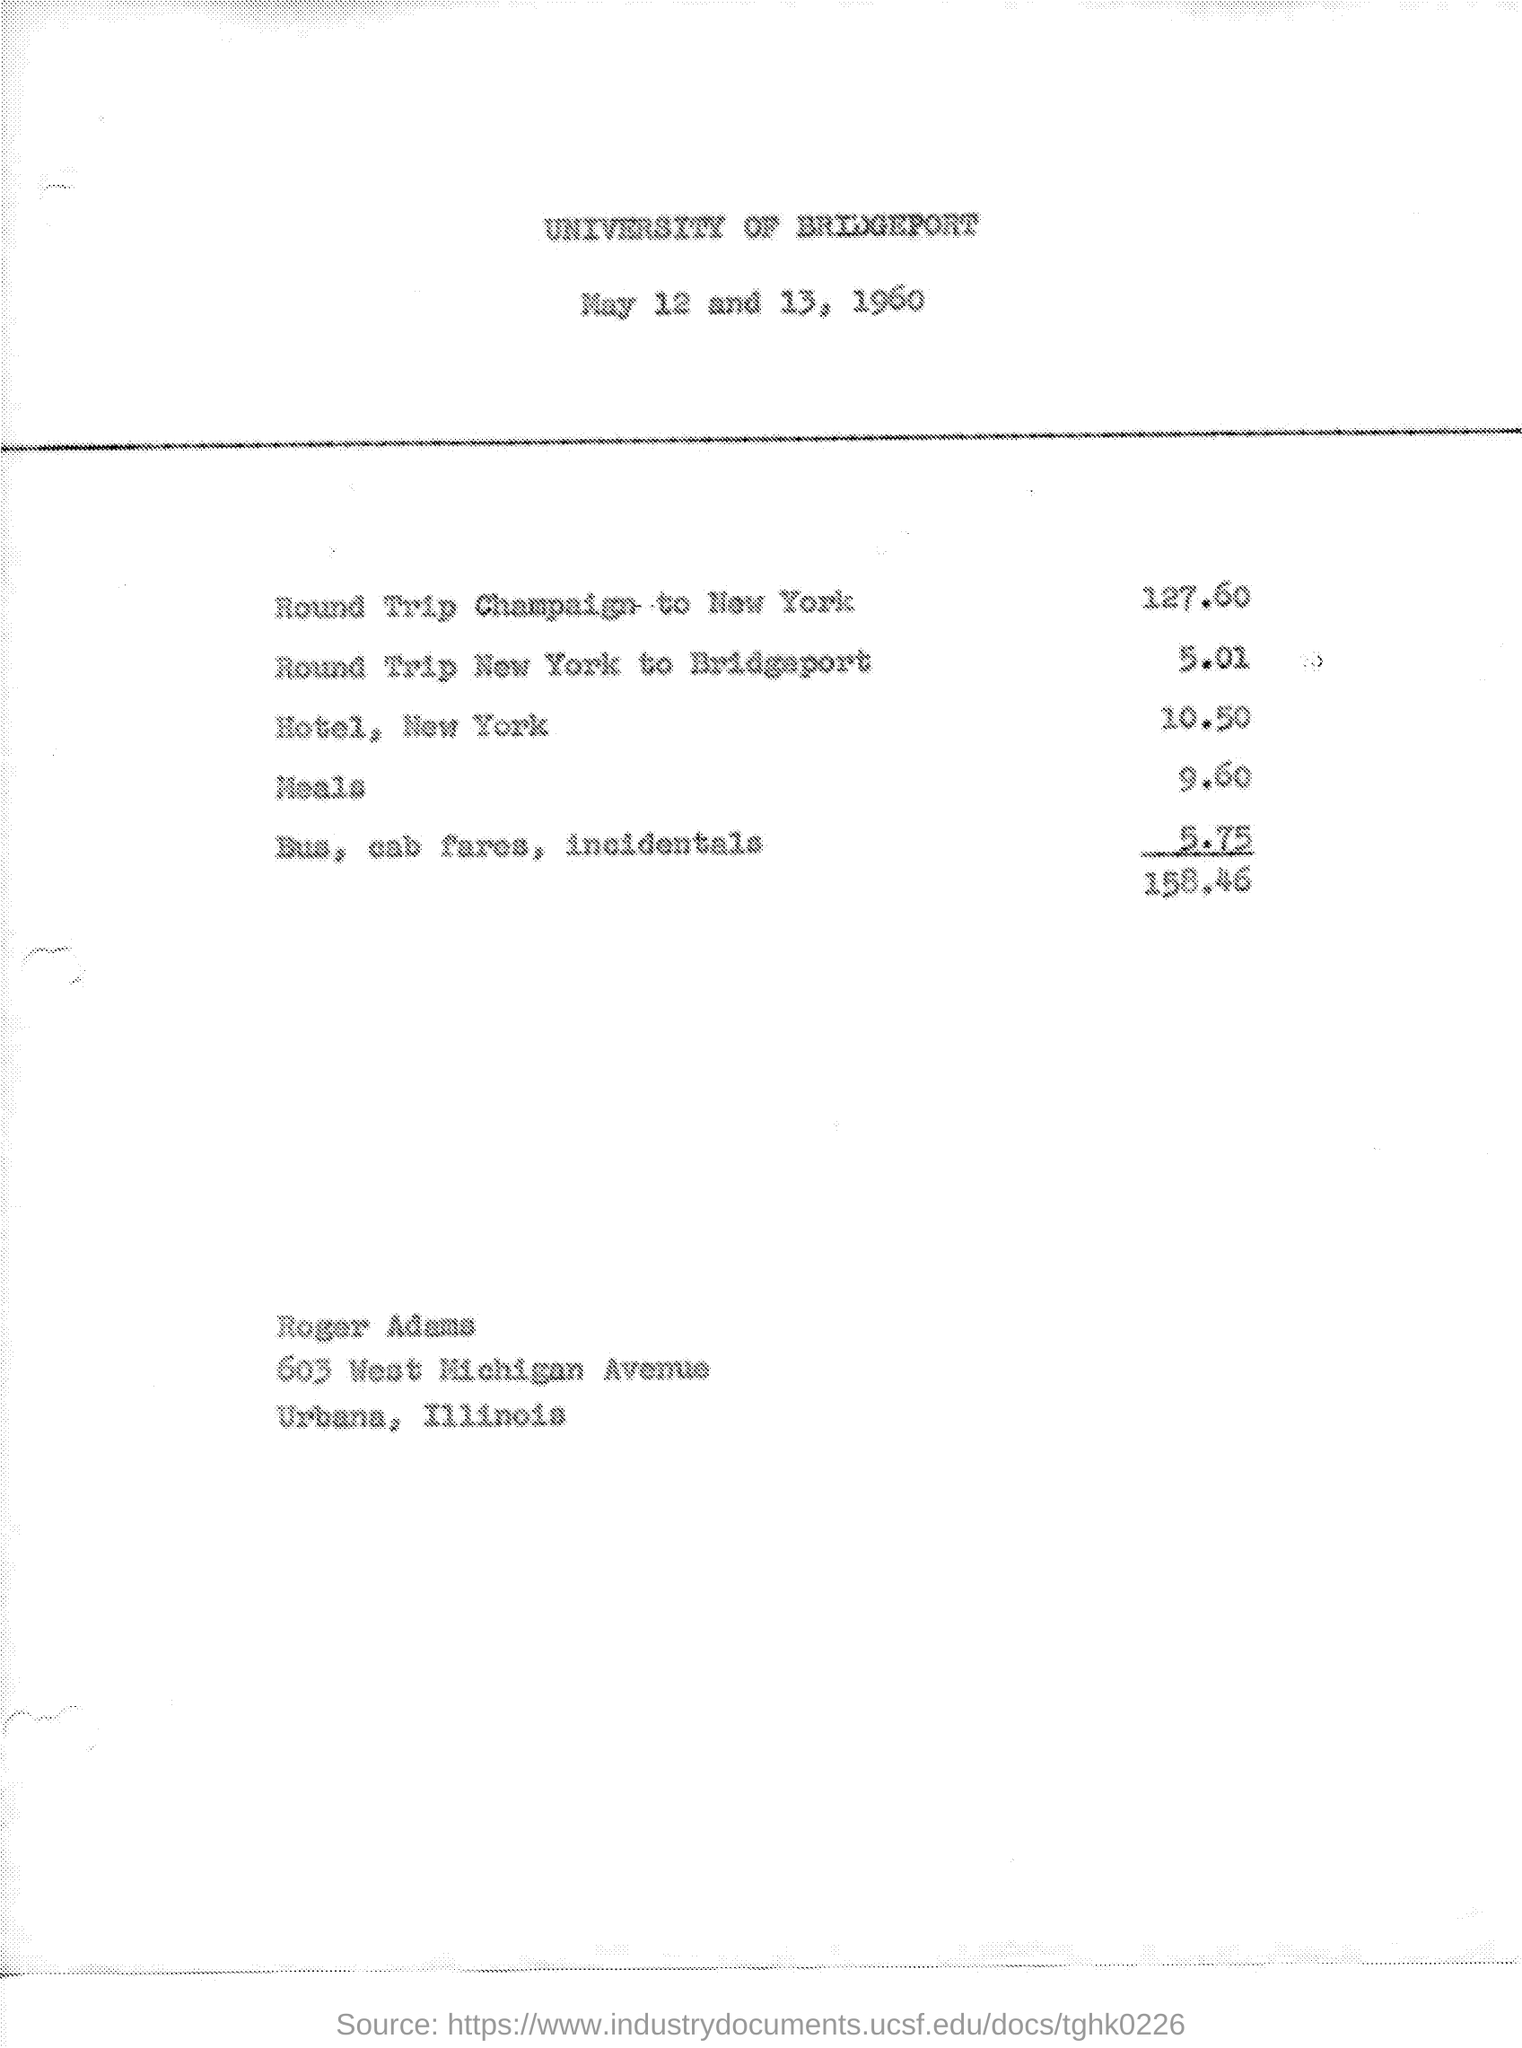What is the date on the document?
Offer a terse response. May 12 and 13, 1960. What is the cost for Round trip champaign to New York?
Give a very brief answer. 127.60. What is the cost for Round trip New York to Bridgeport?
Give a very brief answer. 5.01. What is the cost for Hotel, New York?
Your answer should be compact. 10.50. What is the cost for Meals?
Provide a succinct answer. 9.60. What is the cost for Bus, cab fares, incidentals?
Provide a succinct answer. 5.75. 